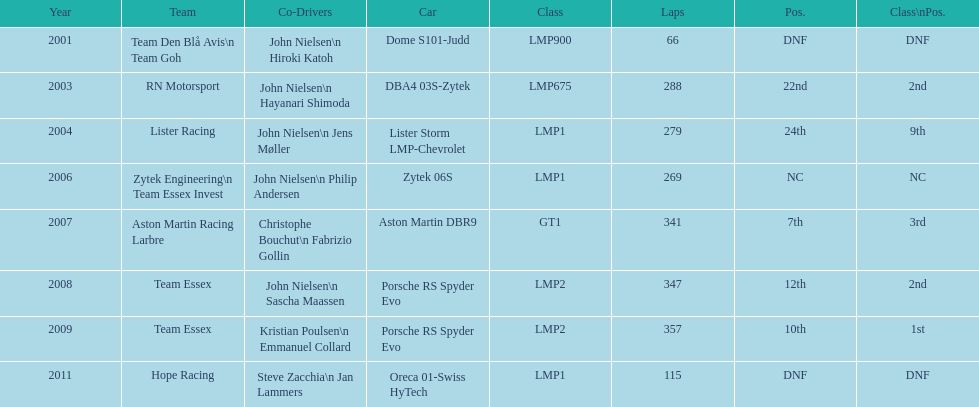What is the amount races that were competed in? 8. 